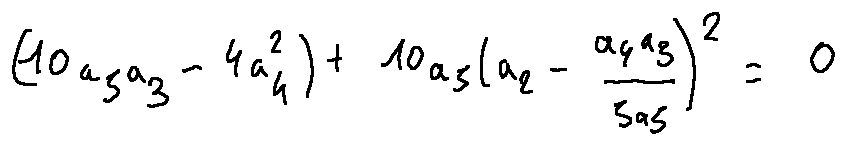<formula> <loc_0><loc_0><loc_500><loc_500>( 1 0 a _ { 5 } a _ { 3 } - 4 a _ { 4 } ^ { 2 } ) + 1 0 a _ { 5 } ( a _ { 2 } - \frac { a _ { 4 } a _ { 3 } } { 5 a _ { 5 } } ) ^ { 2 } = 0</formula> 